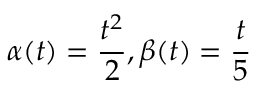<formula> <loc_0><loc_0><loc_500><loc_500>\alpha ( t ) = \frac { t ^ { 2 } } { 2 } , \beta ( t ) = \frac { t } { 5 }</formula> 